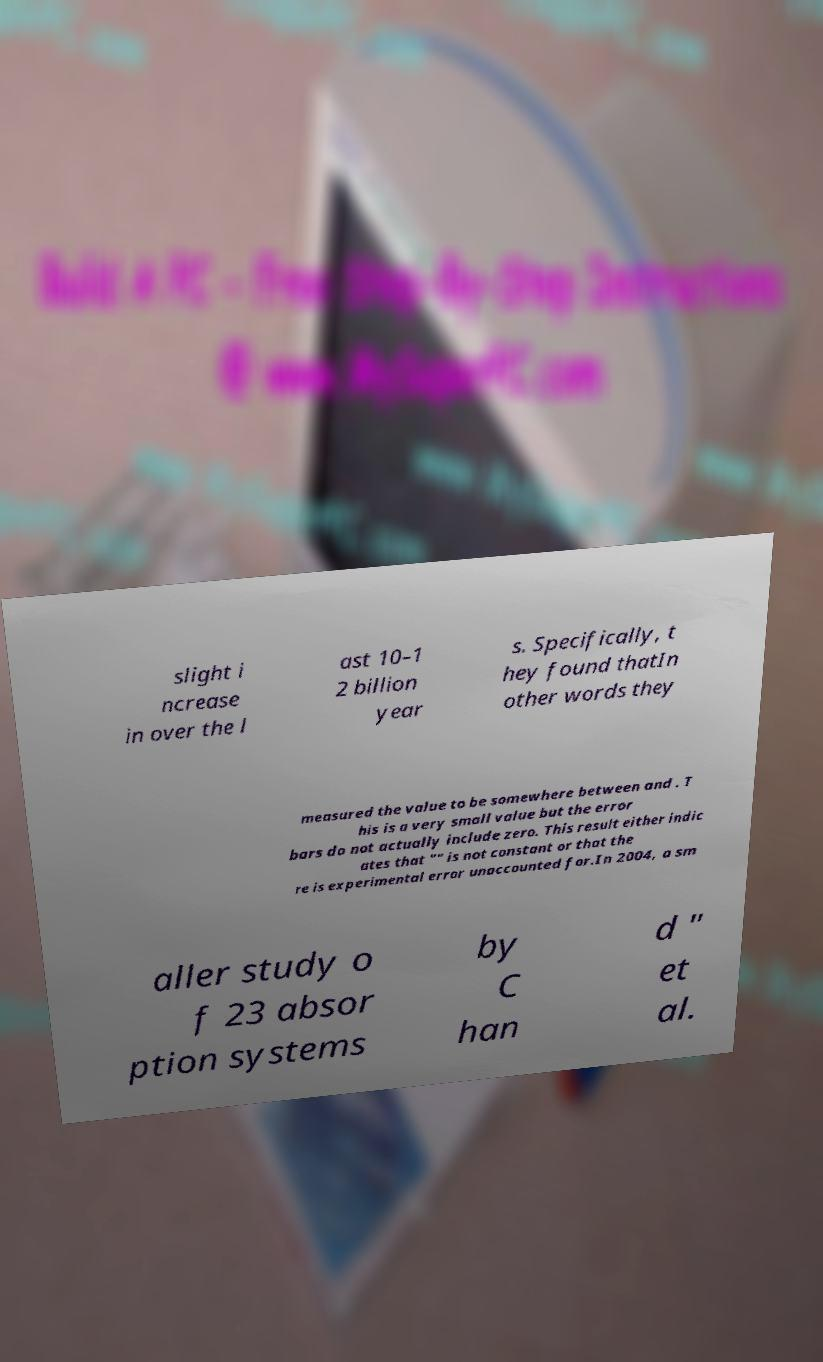I need the written content from this picture converted into text. Can you do that? slight i ncrease in over the l ast 10–1 2 billion year s. Specifically, t hey found thatIn other words they measured the value to be somewhere between and . T his is a very small value but the error bars do not actually include zero. This result either indic ates that "" is not constant or that the re is experimental error unaccounted for.In 2004, a sm aller study o f 23 absor ption systems by C han d " et al. 